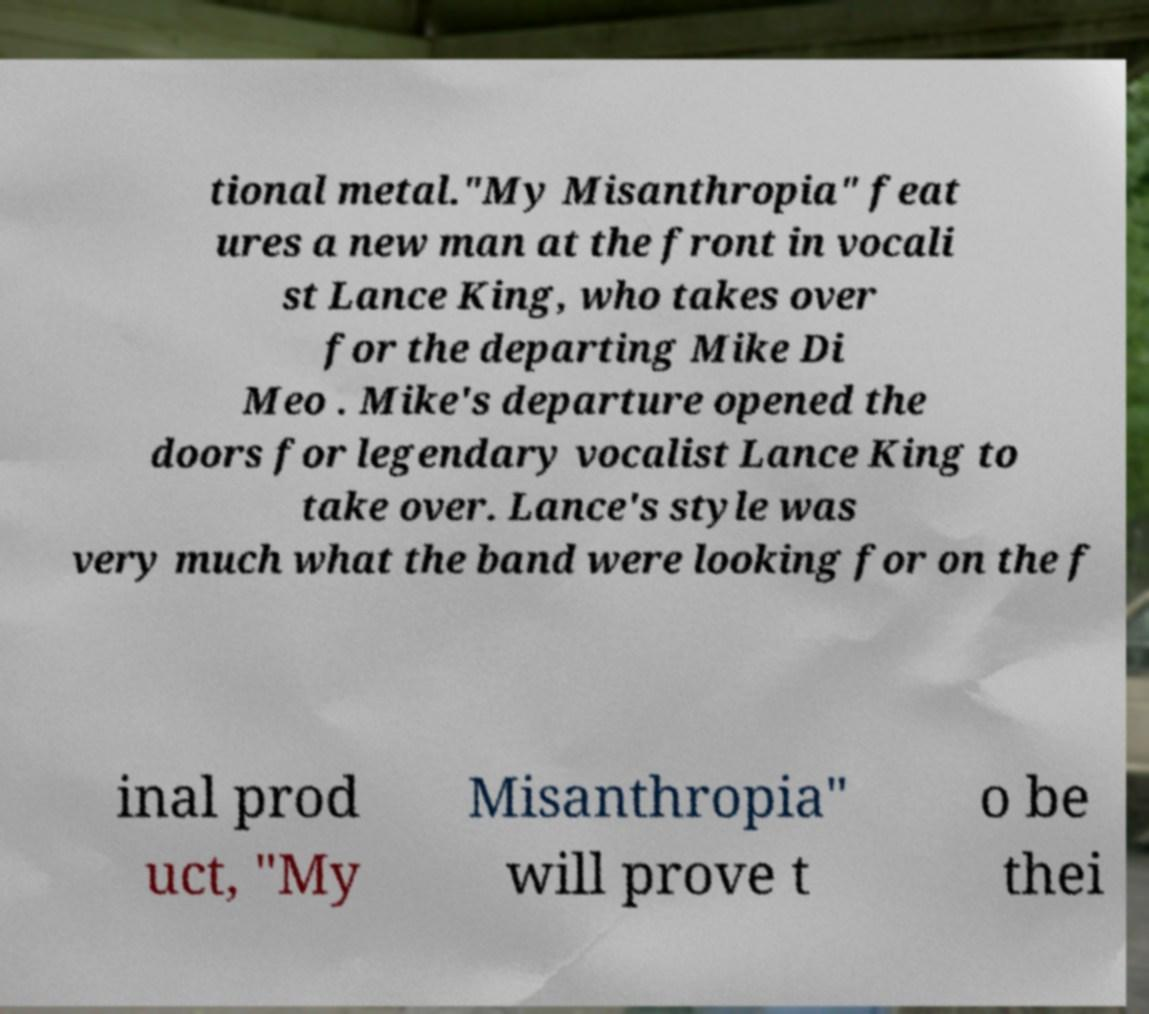Can you read and provide the text displayed in the image?This photo seems to have some interesting text. Can you extract and type it out for me? tional metal."My Misanthropia" feat ures a new man at the front in vocali st Lance King, who takes over for the departing Mike Di Meo . Mike's departure opened the doors for legendary vocalist Lance King to take over. Lance's style was very much what the band were looking for on the f inal prod uct, "My Misanthropia" will prove t o be thei 